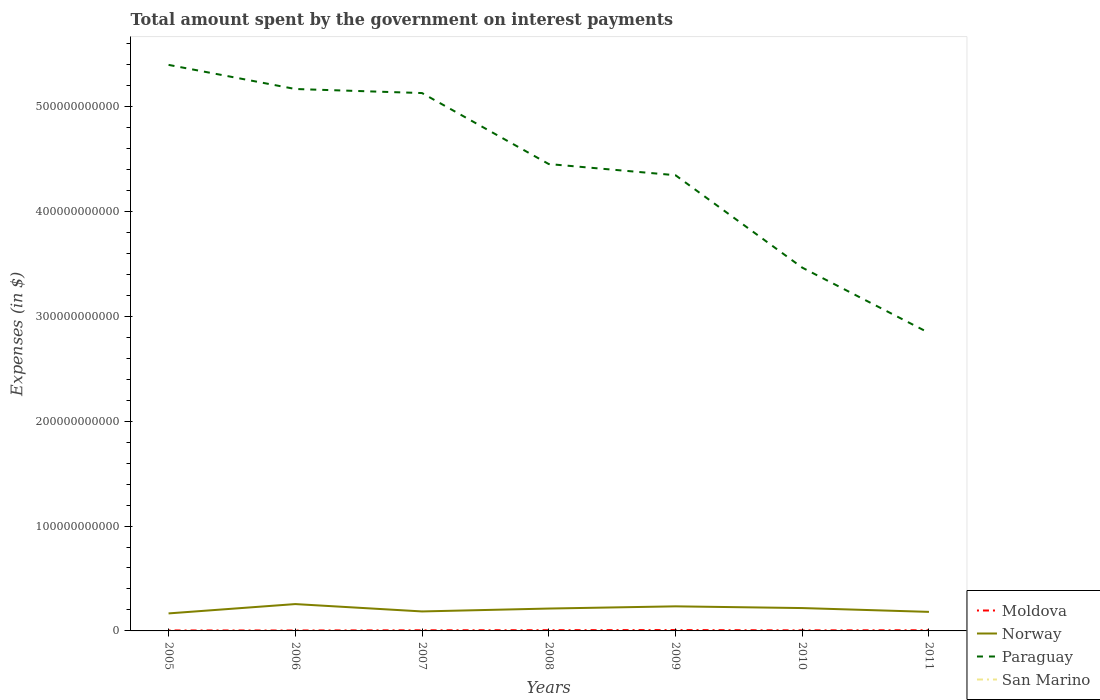How many different coloured lines are there?
Make the answer very short. 4. Across all years, what is the maximum amount spent on interest payments by the government in Norway?
Make the answer very short. 1.67e+1. What is the total amount spent on interest payments by the government in San Marino in the graph?
Your response must be concise. -2.39e+05. What is the difference between the highest and the second highest amount spent on interest payments by the government in Norway?
Make the answer very short. 8.89e+09. What is the difference between the highest and the lowest amount spent on interest payments by the government in Paraguay?
Ensure brevity in your answer.  4. Is the amount spent on interest payments by the government in Moldova strictly greater than the amount spent on interest payments by the government in Norway over the years?
Keep it short and to the point. Yes. How many lines are there?
Offer a terse response. 4. How many years are there in the graph?
Make the answer very short. 7. What is the difference between two consecutive major ticks on the Y-axis?
Provide a succinct answer. 1.00e+11. Are the values on the major ticks of Y-axis written in scientific E-notation?
Ensure brevity in your answer.  No. Does the graph contain any zero values?
Your answer should be very brief. No. Does the graph contain grids?
Provide a short and direct response. No. How many legend labels are there?
Provide a succinct answer. 4. How are the legend labels stacked?
Offer a very short reply. Vertical. What is the title of the graph?
Give a very brief answer. Total amount spent by the government on interest payments. What is the label or title of the Y-axis?
Give a very brief answer. Expenses (in $). What is the Expenses (in $) of Moldova in 2005?
Your response must be concise. 4.70e+08. What is the Expenses (in $) in Norway in 2005?
Your answer should be very brief. 1.67e+1. What is the Expenses (in $) of Paraguay in 2005?
Keep it short and to the point. 5.40e+11. What is the Expenses (in $) in San Marino in 2005?
Give a very brief answer. 2.77e+06. What is the Expenses (in $) of Moldova in 2006?
Your response must be concise. 4.29e+08. What is the Expenses (in $) in Norway in 2006?
Provide a short and direct response. 2.56e+1. What is the Expenses (in $) in Paraguay in 2006?
Your answer should be compact. 5.17e+11. What is the Expenses (in $) in San Marino in 2006?
Your response must be concise. 1.10e+07. What is the Expenses (in $) in Moldova in 2007?
Provide a succinct answer. 6.10e+08. What is the Expenses (in $) of Norway in 2007?
Give a very brief answer. 1.86e+1. What is the Expenses (in $) in Paraguay in 2007?
Your response must be concise. 5.13e+11. What is the Expenses (in $) in San Marino in 2007?
Provide a short and direct response. 1.27e+07. What is the Expenses (in $) of Moldova in 2008?
Offer a terse response. 7.22e+08. What is the Expenses (in $) of Norway in 2008?
Your answer should be very brief. 2.13e+1. What is the Expenses (in $) of Paraguay in 2008?
Give a very brief answer. 4.45e+11. What is the Expenses (in $) in San Marino in 2008?
Ensure brevity in your answer.  5.97e+06. What is the Expenses (in $) in Moldova in 2009?
Offer a very short reply. 8.34e+08. What is the Expenses (in $) of Norway in 2009?
Your answer should be very brief. 2.34e+1. What is the Expenses (in $) of Paraguay in 2009?
Your response must be concise. 4.35e+11. What is the Expenses (in $) in San Marino in 2009?
Your answer should be very brief. 6.45e+06. What is the Expenses (in $) of Moldova in 2010?
Make the answer very short. 5.48e+08. What is the Expenses (in $) of Norway in 2010?
Provide a short and direct response. 2.18e+1. What is the Expenses (in $) in Paraguay in 2010?
Keep it short and to the point. 3.46e+11. What is the Expenses (in $) of San Marino in 2010?
Offer a terse response. 4.65e+06. What is the Expenses (in $) of Moldova in 2011?
Give a very brief answer. 6.62e+08. What is the Expenses (in $) in Norway in 2011?
Your response must be concise. 1.82e+1. What is the Expenses (in $) in Paraguay in 2011?
Keep it short and to the point. 2.84e+11. What is the Expenses (in $) of San Marino in 2011?
Offer a terse response. 4.89e+06. Across all years, what is the maximum Expenses (in $) of Moldova?
Your answer should be very brief. 8.34e+08. Across all years, what is the maximum Expenses (in $) in Norway?
Make the answer very short. 2.56e+1. Across all years, what is the maximum Expenses (in $) of Paraguay?
Ensure brevity in your answer.  5.40e+11. Across all years, what is the maximum Expenses (in $) in San Marino?
Give a very brief answer. 1.27e+07. Across all years, what is the minimum Expenses (in $) in Moldova?
Make the answer very short. 4.29e+08. Across all years, what is the minimum Expenses (in $) in Norway?
Your answer should be very brief. 1.67e+1. Across all years, what is the minimum Expenses (in $) in Paraguay?
Give a very brief answer. 2.84e+11. Across all years, what is the minimum Expenses (in $) of San Marino?
Ensure brevity in your answer.  2.77e+06. What is the total Expenses (in $) in Moldova in the graph?
Your answer should be compact. 4.27e+09. What is the total Expenses (in $) in Norway in the graph?
Your answer should be very brief. 1.46e+11. What is the total Expenses (in $) of Paraguay in the graph?
Offer a very short reply. 3.08e+12. What is the total Expenses (in $) in San Marino in the graph?
Your answer should be very brief. 4.84e+07. What is the difference between the Expenses (in $) in Moldova in 2005 and that in 2006?
Provide a short and direct response. 4.19e+07. What is the difference between the Expenses (in $) of Norway in 2005 and that in 2006?
Offer a very short reply. -8.89e+09. What is the difference between the Expenses (in $) of Paraguay in 2005 and that in 2006?
Offer a very short reply. 2.30e+1. What is the difference between the Expenses (in $) in San Marino in 2005 and that in 2006?
Give a very brief answer. -8.20e+06. What is the difference between the Expenses (in $) of Moldova in 2005 and that in 2007?
Provide a short and direct response. -1.39e+08. What is the difference between the Expenses (in $) in Norway in 2005 and that in 2007?
Provide a short and direct response. -1.88e+09. What is the difference between the Expenses (in $) in Paraguay in 2005 and that in 2007?
Keep it short and to the point. 2.69e+1. What is the difference between the Expenses (in $) in San Marino in 2005 and that in 2007?
Offer a terse response. -9.97e+06. What is the difference between the Expenses (in $) of Moldova in 2005 and that in 2008?
Keep it short and to the point. -2.51e+08. What is the difference between the Expenses (in $) in Norway in 2005 and that in 2008?
Offer a terse response. -4.63e+09. What is the difference between the Expenses (in $) in Paraguay in 2005 and that in 2008?
Your response must be concise. 9.46e+1. What is the difference between the Expenses (in $) of San Marino in 2005 and that in 2008?
Offer a terse response. -3.20e+06. What is the difference between the Expenses (in $) of Moldova in 2005 and that in 2009?
Give a very brief answer. -3.64e+08. What is the difference between the Expenses (in $) in Norway in 2005 and that in 2009?
Your response must be concise. -6.74e+09. What is the difference between the Expenses (in $) in Paraguay in 2005 and that in 2009?
Offer a terse response. 1.05e+11. What is the difference between the Expenses (in $) in San Marino in 2005 and that in 2009?
Your response must be concise. -3.67e+06. What is the difference between the Expenses (in $) of Moldova in 2005 and that in 2010?
Your answer should be compact. -7.71e+07. What is the difference between the Expenses (in $) of Norway in 2005 and that in 2010?
Provide a succinct answer. -5.10e+09. What is the difference between the Expenses (in $) in Paraguay in 2005 and that in 2010?
Provide a succinct answer. 1.93e+11. What is the difference between the Expenses (in $) in San Marino in 2005 and that in 2010?
Your response must be concise. -1.88e+06. What is the difference between the Expenses (in $) of Moldova in 2005 and that in 2011?
Offer a very short reply. -1.92e+08. What is the difference between the Expenses (in $) of Norway in 2005 and that in 2011?
Provide a short and direct response. -1.46e+09. What is the difference between the Expenses (in $) in Paraguay in 2005 and that in 2011?
Ensure brevity in your answer.  2.56e+11. What is the difference between the Expenses (in $) in San Marino in 2005 and that in 2011?
Ensure brevity in your answer.  -2.12e+06. What is the difference between the Expenses (in $) of Moldova in 2006 and that in 2007?
Offer a terse response. -1.81e+08. What is the difference between the Expenses (in $) of Norway in 2006 and that in 2007?
Offer a very short reply. 7.01e+09. What is the difference between the Expenses (in $) of Paraguay in 2006 and that in 2007?
Make the answer very short. 3.87e+09. What is the difference between the Expenses (in $) of San Marino in 2006 and that in 2007?
Your response must be concise. -1.77e+06. What is the difference between the Expenses (in $) of Moldova in 2006 and that in 2008?
Ensure brevity in your answer.  -2.93e+08. What is the difference between the Expenses (in $) in Norway in 2006 and that in 2008?
Keep it short and to the point. 4.26e+09. What is the difference between the Expenses (in $) of Paraguay in 2006 and that in 2008?
Offer a very short reply. 7.16e+1. What is the difference between the Expenses (in $) in San Marino in 2006 and that in 2008?
Your response must be concise. 5.00e+06. What is the difference between the Expenses (in $) in Moldova in 2006 and that in 2009?
Make the answer very short. -4.06e+08. What is the difference between the Expenses (in $) in Norway in 2006 and that in 2009?
Keep it short and to the point. 2.15e+09. What is the difference between the Expenses (in $) in Paraguay in 2006 and that in 2009?
Make the answer very short. 8.22e+1. What is the difference between the Expenses (in $) in San Marino in 2006 and that in 2009?
Provide a short and direct response. 4.52e+06. What is the difference between the Expenses (in $) of Moldova in 2006 and that in 2010?
Make the answer very short. -1.19e+08. What is the difference between the Expenses (in $) in Norway in 2006 and that in 2010?
Your answer should be compact. 3.79e+09. What is the difference between the Expenses (in $) in Paraguay in 2006 and that in 2010?
Offer a very short reply. 1.70e+11. What is the difference between the Expenses (in $) in San Marino in 2006 and that in 2010?
Provide a short and direct response. 6.32e+06. What is the difference between the Expenses (in $) in Moldova in 2006 and that in 2011?
Make the answer very short. -2.34e+08. What is the difference between the Expenses (in $) of Norway in 2006 and that in 2011?
Keep it short and to the point. 7.43e+09. What is the difference between the Expenses (in $) of Paraguay in 2006 and that in 2011?
Ensure brevity in your answer.  2.33e+11. What is the difference between the Expenses (in $) in San Marino in 2006 and that in 2011?
Ensure brevity in your answer.  6.08e+06. What is the difference between the Expenses (in $) in Moldova in 2007 and that in 2008?
Your response must be concise. -1.12e+08. What is the difference between the Expenses (in $) of Norway in 2007 and that in 2008?
Ensure brevity in your answer.  -2.75e+09. What is the difference between the Expenses (in $) in Paraguay in 2007 and that in 2008?
Your answer should be very brief. 6.77e+1. What is the difference between the Expenses (in $) of San Marino in 2007 and that in 2008?
Provide a short and direct response. 6.77e+06. What is the difference between the Expenses (in $) in Moldova in 2007 and that in 2009?
Provide a succinct answer. -2.24e+08. What is the difference between the Expenses (in $) in Norway in 2007 and that in 2009?
Keep it short and to the point. -4.86e+09. What is the difference between the Expenses (in $) in Paraguay in 2007 and that in 2009?
Offer a terse response. 7.83e+1. What is the difference between the Expenses (in $) of San Marino in 2007 and that in 2009?
Your answer should be very brief. 6.29e+06. What is the difference between the Expenses (in $) of Moldova in 2007 and that in 2010?
Provide a short and direct response. 6.22e+07. What is the difference between the Expenses (in $) of Norway in 2007 and that in 2010?
Your response must be concise. -3.22e+09. What is the difference between the Expenses (in $) of Paraguay in 2007 and that in 2010?
Provide a short and direct response. 1.66e+11. What is the difference between the Expenses (in $) in San Marino in 2007 and that in 2010?
Give a very brief answer. 8.09e+06. What is the difference between the Expenses (in $) of Moldova in 2007 and that in 2011?
Your answer should be compact. -5.26e+07. What is the difference between the Expenses (in $) in Norway in 2007 and that in 2011?
Your response must be concise. 4.20e+08. What is the difference between the Expenses (in $) in Paraguay in 2007 and that in 2011?
Make the answer very short. 2.29e+11. What is the difference between the Expenses (in $) of San Marino in 2007 and that in 2011?
Provide a short and direct response. 7.85e+06. What is the difference between the Expenses (in $) in Moldova in 2008 and that in 2009?
Your answer should be compact. -1.13e+08. What is the difference between the Expenses (in $) of Norway in 2008 and that in 2009?
Your response must be concise. -2.11e+09. What is the difference between the Expenses (in $) in Paraguay in 2008 and that in 2009?
Provide a short and direct response. 1.06e+1. What is the difference between the Expenses (in $) of San Marino in 2008 and that in 2009?
Keep it short and to the point. -4.76e+05. What is the difference between the Expenses (in $) of Moldova in 2008 and that in 2010?
Keep it short and to the point. 1.74e+08. What is the difference between the Expenses (in $) of Norway in 2008 and that in 2010?
Offer a terse response. -4.70e+08. What is the difference between the Expenses (in $) of Paraguay in 2008 and that in 2010?
Ensure brevity in your answer.  9.87e+1. What is the difference between the Expenses (in $) of San Marino in 2008 and that in 2010?
Offer a terse response. 1.32e+06. What is the difference between the Expenses (in $) in Moldova in 2008 and that in 2011?
Your response must be concise. 5.92e+07. What is the difference between the Expenses (in $) of Norway in 2008 and that in 2011?
Offer a very short reply. 3.17e+09. What is the difference between the Expenses (in $) in Paraguay in 2008 and that in 2011?
Provide a succinct answer. 1.61e+11. What is the difference between the Expenses (in $) of San Marino in 2008 and that in 2011?
Ensure brevity in your answer.  1.08e+06. What is the difference between the Expenses (in $) of Moldova in 2009 and that in 2010?
Offer a terse response. 2.87e+08. What is the difference between the Expenses (in $) of Norway in 2009 and that in 2010?
Your answer should be compact. 1.64e+09. What is the difference between the Expenses (in $) of Paraguay in 2009 and that in 2010?
Make the answer very short. 8.81e+1. What is the difference between the Expenses (in $) in San Marino in 2009 and that in 2010?
Offer a terse response. 1.79e+06. What is the difference between the Expenses (in $) of Moldova in 2009 and that in 2011?
Your response must be concise. 1.72e+08. What is the difference between the Expenses (in $) in Norway in 2009 and that in 2011?
Keep it short and to the point. 5.28e+09. What is the difference between the Expenses (in $) in Paraguay in 2009 and that in 2011?
Make the answer very short. 1.50e+11. What is the difference between the Expenses (in $) in San Marino in 2009 and that in 2011?
Your response must be concise. 1.56e+06. What is the difference between the Expenses (in $) of Moldova in 2010 and that in 2011?
Ensure brevity in your answer.  -1.15e+08. What is the difference between the Expenses (in $) in Norway in 2010 and that in 2011?
Your response must be concise. 3.64e+09. What is the difference between the Expenses (in $) of Paraguay in 2010 and that in 2011?
Offer a terse response. 6.23e+1. What is the difference between the Expenses (in $) of San Marino in 2010 and that in 2011?
Your answer should be compact. -2.39e+05. What is the difference between the Expenses (in $) of Moldova in 2005 and the Expenses (in $) of Norway in 2006?
Your answer should be compact. -2.51e+1. What is the difference between the Expenses (in $) in Moldova in 2005 and the Expenses (in $) in Paraguay in 2006?
Your answer should be very brief. -5.16e+11. What is the difference between the Expenses (in $) in Moldova in 2005 and the Expenses (in $) in San Marino in 2006?
Your answer should be compact. 4.60e+08. What is the difference between the Expenses (in $) in Norway in 2005 and the Expenses (in $) in Paraguay in 2006?
Offer a very short reply. -5.00e+11. What is the difference between the Expenses (in $) of Norway in 2005 and the Expenses (in $) of San Marino in 2006?
Your response must be concise. 1.67e+1. What is the difference between the Expenses (in $) of Paraguay in 2005 and the Expenses (in $) of San Marino in 2006?
Provide a short and direct response. 5.40e+11. What is the difference between the Expenses (in $) in Moldova in 2005 and the Expenses (in $) in Norway in 2007?
Make the answer very short. -1.81e+1. What is the difference between the Expenses (in $) in Moldova in 2005 and the Expenses (in $) in Paraguay in 2007?
Give a very brief answer. -5.12e+11. What is the difference between the Expenses (in $) in Moldova in 2005 and the Expenses (in $) in San Marino in 2007?
Your answer should be compact. 4.58e+08. What is the difference between the Expenses (in $) of Norway in 2005 and the Expenses (in $) of Paraguay in 2007?
Provide a short and direct response. -4.96e+11. What is the difference between the Expenses (in $) of Norway in 2005 and the Expenses (in $) of San Marino in 2007?
Your response must be concise. 1.67e+1. What is the difference between the Expenses (in $) in Paraguay in 2005 and the Expenses (in $) in San Marino in 2007?
Provide a succinct answer. 5.40e+11. What is the difference between the Expenses (in $) in Moldova in 2005 and the Expenses (in $) in Norway in 2008?
Give a very brief answer. -2.09e+1. What is the difference between the Expenses (in $) in Moldova in 2005 and the Expenses (in $) in Paraguay in 2008?
Offer a terse response. -4.45e+11. What is the difference between the Expenses (in $) in Moldova in 2005 and the Expenses (in $) in San Marino in 2008?
Offer a very short reply. 4.65e+08. What is the difference between the Expenses (in $) of Norway in 2005 and the Expenses (in $) of Paraguay in 2008?
Your answer should be compact. -4.28e+11. What is the difference between the Expenses (in $) in Norway in 2005 and the Expenses (in $) in San Marino in 2008?
Give a very brief answer. 1.67e+1. What is the difference between the Expenses (in $) of Paraguay in 2005 and the Expenses (in $) of San Marino in 2008?
Ensure brevity in your answer.  5.40e+11. What is the difference between the Expenses (in $) in Moldova in 2005 and the Expenses (in $) in Norway in 2009?
Provide a short and direct response. -2.30e+1. What is the difference between the Expenses (in $) in Moldova in 2005 and the Expenses (in $) in Paraguay in 2009?
Give a very brief answer. -4.34e+11. What is the difference between the Expenses (in $) of Moldova in 2005 and the Expenses (in $) of San Marino in 2009?
Provide a short and direct response. 4.64e+08. What is the difference between the Expenses (in $) of Norway in 2005 and the Expenses (in $) of Paraguay in 2009?
Keep it short and to the point. -4.18e+11. What is the difference between the Expenses (in $) in Norway in 2005 and the Expenses (in $) in San Marino in 2009?
Offer a terse response. 1.67e+1. What is the difference between the Expenses (in $) of Paraguay in 2005 and the Expenses (in $) of San Marino in 2009?
Your answer should be very brief. 5.40e+11. What is the difference between the Expenses (in $) of Moldova in 2005 and the Expenses (in $) of Norway in 2010?
Keep it short and to the point. -2.13e+1. What is the difference between the Expenses (in $) in Moldova in 2005 and the Expenses (in $) in Paraguay in 2010?
Your answer should be very brief. -3.46e+11. What is the difference between the Expenses (in $) of Moldova in 2005 and the Expenses (in $) of San Marino in 2010?
Offer a very short reply. 4.66e+08. What is the difference between the Expenses (in $) in Norway in 2005 and the Expenses (in $) in Paraguay in 2010?
Keep it short and to the point. -3.30e+11. What is the difference between the Expenses (in $) of Norway in 2005 and the Expenses (in $) of San Marino in 2010?
Provide a succinct answer. 1.67e+1. What is the difference between the Expenses (in $) in Paraguay in 2005 and the Expenses (in $) in San Marino in 2010?
Provide a short and direct response. 5.40e+11. What is the difference between the Expenses (in $) of Moldova in 2005 and the Expenses (in $) of Norway in 2011?
Your answer should be very brief. -1.77e+1. What is the difference between the Expenses (in $) in Moldova in 2005 and the Expenses (in $) in Paraguay in 2011?
Provide a succinct answer. -2.84e+11. What is the difference between the Expenses (in $) in Moldova in 2005 and the Expenses (in $) in San Marino in 2011?
Provide a short and direct response. 4.66e+08. What is the difference between the Expenses (in $) of Norway in 2005 and the Expenses (in $) of Paraguay in 2011?
Offer a terse response. -2.67e+11. What is the difference between the Expenses (in $) of Norway in 2005 and the Expenses (in $) of San Marino in 2011?
Give a very brief answer. 1.67e+1. What is the difference between the Expenses (in $) in Paraguay in 2005 and the Expenses (in $) in San Marino in 2011?
Keep it short and to the point. 5.40e+11. What is the difference between the Expenses (in $) of Moldova in 2006 and the Expenses (in $) of Norway in 2007?
Your answer should be very brief. -1.82e+1. What is the difference between the Expenses (in $) in Moldova in 2006 and the Expenses (in $) in Paraguay in 2007?
Keep it short and to the point. -5.12e+11. What is the difference between the Expenses (in $) of Moldova in 2006 and the Expenses (in $) of San Marino in 2007?
Give a very brief answer. 4.16e+08. What is the difference between the Expenses (in $) of Norway in 2006 and the Expenses (in $) of Paraguay in 2007?
Give a very brief answer. -4.87e+11. What is the difference between the Expenses (in $) in Norway in 2006 and the Expenses (in $) in San Marino in 2007?
Your response must be concise. 2.56e+1. What is the difference between the Expenses (in $) in Paraguay in 2006 and the Expenses (in $) in San Marino in 2007?
Give a very brief answer. 5.17e+11. What is the difference between the Expenses (in $) of Moldova in 2006 and the Expenses (in $) of Norway in 2008?
Ensure brevity in your answer.  -2.09e+1. What is the difference between the Expenses (in $) in Moldova in 2006 and the Expenses (in $) in Paraguay in 2008?
Make the answer very short. -4.45e+11. What is the difference between the Expenses (in $) of Moldova in 2006 and the Expenses (in $) of San Marino in 2008?
Your answer should be very brief. 4.23e+08. What is the difference between the Expenses (in $) of Norway in 2006 and the Expenses (in $) of Paraguay in 2008?
Give a very brief answer. -4.20e+11. What is the difference between the Expenses (in $) of Norway in 2006 and the Expenses (in $) of San Marino in 2008?
Ensure brevity in your answer.  2.56e+1. What is the difference between the Expenses (in $) of Paraguay in 2006 and the Expenses (in $) of San Marino in 2008?
Provide a short and direct response. 5.17e+11. What is the difference between the Expenses (in $) of Moldova in 2006 and the Expenses (in $) of Norway in 2009?
Offer a very short reply. -2.30e+1. What is the difference between the Expenses (in $) of Moldova in 2006 and the Expenses (in $) of Paraguay in 2009?
Make the answer very short. -4.34e+11. What is the difference between the Expenses (in $) in Moldova in 2006 and the Expenses (in $) in San Marino in 2009?
Your answer should be compact. 4.22e+08. What is the difference between the Expenses (in $) of Norway in 2006 and the Expenses (in $) of Paraguay in 2009?
Give a very brief answer. -4.09e+11. What is the difference between the Expenses (in $) of Norway in 2006 and the Expenses (in $) of San Marino in 2009?
Offer a terse response. 2.56e+1. What is the difference between the Expenses (in $) in Paraguay in 2006 and the Expenses (in $) in San Marino in 2009?
Ensure brevity in your answer.  5.17e+11. What is the difference between the Expenses (in $) of Moldova in 2006 and the Expenses (in $) of Norway in 2010?
Offer a terse response. -2.14e+1. What is the difference between the Expenses (in $) of Moldova in 2006 and the Expenses (in $) of Paraguay in 2010?
Ensure brevity in your answer.  -3.46e+11. What is the difference between the Expenses (in $) of Moldova in 2006 and the Expenses (in $) of San Marino in 2010?
Your answer should be very brief. 4.24e+08. What is the difference between the Expenses (in $) of Norway in 2006 and the Expenses (in $) of Paraguay in 2010?
Offer a very short reply. -3.21e+11. What is the difference between the Expenses (in $) in Norway in 2006 and the Expenses (in $) in San Marino in 2010?
Offer a terse response. 2.56e+1. What is the difference between the Expenses (in $) of Paraguay in 2006 and the Expenses (in $) of San Marino in 2010?
Your response must be concise. 5.17e+11. What is the difference between the Expenses (in $) in Moldova in 2006 and the Expenses (in $) in Norway in 2011?
Offer a very short reply. -1.77e+1. What is the difference between the Expenses (in $) in Moldova in 2006 and the Expenses (in $) in Paraguay in 2011?
Offer a very short reply. -2.84e+11. What is the difference between the Expenses (in $) in Moldova in 2006 and the Expenses (in $) in San Marino in 2011?
Provide a short and direct response. 4.24e+08. What is the difference between the Expenses (in $) in Norway in 2006 and the Expenses (in $) in Paraguay in 2011?
Offer a very short reply. -2.59e+11. What is the difference between the Expenses (in $) in Norway in 2006 and the Expenses (in $) in San Marino in 2011?
Your answer should be compact. 2.56e+1. What is the difference between the Expenses (in $) of Paraguay in 2006 and the Expenses (in $) of San Marino in 2011?
Your answer should be compact. 5.17e+11. What is the difference between the Expenses (in $) of Moldova in 2007 and the Expenses (in $) of Norway in 2008?
Keep it short and to the point. -2.07e+1. What is the difference between the Expenses (in $) in Moldova in 2007 and the Expenses (in $) in Paraguay in 2008?
Your answer should be very brief. -4.45e+11. What is the difference between the Expenses (in $) of Moldova in 2007 and the Expenses (in $) of San Marino in 2008?
Your response must be concise. 6.04e+08. What is the difference between the Expenses (in $) of Norway in 2007 and the Expenses (in $) of Paraguay in 2008?
Your answer should be compact. -4.27e+11. What is the difference between the Expenses (in $) in Norway in 2007 and the Expenses (in $) in San Marino in 2008?
Your answer should be very brief. 1.86e+1. What is the difference between the Expenses (in $) in Paraguay in 2007 and the Expenses (in $) in San Marino in 2008?
Offer a very short reply. 5.13e+11. What is the difference between the Expenses (in $) of Moldova in 2007 and the Expenses (in $) of Norway in 2009?
Your response must be concise. -2.28e+1. What is the difference between the Expenses (in $) of Moldova in 2007 and the Expenses (in $) of Paraguay in 2009?
Your response must be concise. -4.34e+11. What is the difference between the Expenses (in $) in Moldova in 2007 and the Expenses (in $) in San Marino in 2009?
Provide a succinct answer. 6.03e+08. What is the difference between the Expenses (in $) in Norway in 2007 and the Expenses (in $) in Paraguay in 2009?
Your answer should be very brief. -4.16e+11. What is the difference between the Expenses (in $) of Norway in 2007 and the Expenses (in $) of San Marino in 2009?
Your response must be concise. 1.86e+1. What is the difference between the Expenses (in $) of Paraguay in 2007 and the Expenses (in $) of San Marino in 2009?
Ensure brevity in your answer.  5.13e+11. What is the difference between the Expenses (in $) in Moldova in 2007 and the Expenses (in $) in Norway in 2010?
Offer a very short reply. -2.12e+1. What is the difference between the Expenses (in $) of Moldova in 2007 and the Expenses (in $) of Paraguay in 2010?
Your answer should be compact. -3.46e+11. What is the difference between the Expenses (in $) in Moldova in 2007 and the Expenses (in $) in San Marino in 2010?
Ensure brevity in your answer.  6.05e+08. What is the difference between the Expenses (in $) in Norway in 2007 and the Expenses (in $) in Paraguay in 2010?
Make the answer very short. -3.28e+11. What is the difference between the Expenses (in $) in Norway in 2007 and the Expenses (in $) in San Marino in 2010?
Your response must be concise. 1.86e+1. What is the difference between the Expenses (in $) in Paraguay in 2007 and the Expenses (in $) in San Marino in 2010?
Give a very brief answer. 5.13e+11. What is the difference between the Expenses (in $) in Moldova in 2007 and the Expenses (in $) in Norway in 2011?
Offer a very short reply. -1.76e+1. What is the difference between the Expenses (in $) in Moldova in 2007 and the Expenses (in $) in Paraguay in 2011?
Your response must be concise. -2.84e+11. What is the difference between the Expenses (in $) in Moldova in 2007 and the Expenses (in $) in San Marino in 2011?
Provide a succinct answer. 6.05e+08. What is the difference between the Expenses (in $) in Norway in 2007 and the Expenses (in $) in Paraguay in 2011?
Provide a succinct answer. -2.66e+11. What is the difference between the Expenses (in $) of Norway in 2007 and the Expenses (in $) of San Marino in 2011?
Provide a succinct answer. 1.86e+1. What is the difference between the Expenses (in $) of Paraguay in 2007 and the Expenses (in $) of San Marino in 2011?
Keep it short and to the point. 5.13e+11. What is the difference between the Expenses (in $) in Moldova in 2008 and the Expenses (in $) in Norway in 2009?
Your answer should be very brief. -2.27e+1. What is the difference between the Expenses (in $) of Moldova in 2008 and the Expenses (in $) of Paraguay in 2009?
Provide a short and direct response. -4.34e+11. What is the difference between the Expenses (in $) in Moldova in 2008 and the Expenses (in $) in San Marino in 2009?
Offer a very short reply. 7.15e+08. What is the difference between the Expenses (in $) in Norway in 2008 and the Expenses (in $) in Paraguay in 2009?
Offer a terse response. -4.13e+11. What is the difference between the Expenses (in $) of Norway in 2008 and the Expenses (in $) of San Marino in 2009?
Provide a short and direct response. 2.13e+1. What is the difference between the Expenses (in $) in Paraguay in 2008 and the Expenses (in $) in San Marino in 2009?
Give a very brief answer. 4.45e+11. What is the difference between the Expenses (in $) in Moldova in 2008 and the Expenses (in $) in Norway in 2010?
Your response must be concise. -2.11e+1. What is the difference between the Expenses (in $) of Moldova in 2008 and the Expenses (in $) of Paraguay in 2010?
Provide a short and direct response. -3.46e+11. What is the difference between the Expenses (in $) in Moldova in 2008 and the Expenses (in $) in San Marino in 2010?
Offer a very short reply. 7.17e+08. What is the difference between the Expenses (in $) in Norway in 2008 and the Expenses (in $) in Paraguay in 2010?
Give a very brief answer. -3.25e+11. What is the difference between the Expenses (in $) in Norway in 2008 and the Expenses (in $) in San Marino in 2010?
Make the answer very short. 2.13e+1. What is the difference between the Expenses (in $) in Paraguay in 2008 and the Expenses (in $) in San Marino in 2010?
Give a very brief answer. 4.45e+11. What is the difference between the Expenses (in $) of Moldova in 2008 and the Expenses (in $) of Norway in 2011?
Provide a short and direct response. -1.74e+1. What is the difference between the Expenses (in $) in Moldova in 2008 and the Expenses (in $) in Paraguay in 2011?
Your answer should be compact. -2.83e+11. What is the difference between the Expenses (in $) of Moldova in 2008 and the Expenses (in $) of San Marino in 2011?
Make the answer very short. 7.17e+08. What is the difference between the Expenses (in $) of Norway in 2008 and the Expenses (in $) of Paraguay in 2011?
Make the answer very short. -2.63e+11. What is the difference between the Expenses (in $) of Norway in 2008 and the Expenses (in $) of San Marino in 2011?
Your answer should be very brief. 2.13e+1. What is the difference between the Expenses (in $) in Paraguay in 2008 and the Expenses (in $) in San Marino in 2011?
Your answer should be very brief. 4.45e+11. What is the difference between the Expenses (in $) of Moldova in 2009 and the Expenses (in $) of Norway in 2010?
Keep it short and to the point. -2.10e+1. What is the difference between the Expenses (in $) in Moldova in 2009 and the Expenses (in $) in Paraguay in 2010?
Provide a succinct answer. -3.46e+11. What is the difference between the Expenses (in $) of Moldova in 2009 and the Expenses (in $) of San Marino in 2010?
Keep it short and to the point. 8.30e+08. What is the difference between the Expenses (in $) of Norway in 2009 and the Expenses (in $) of Paraguay in 2010?
Your answer should be compact. -3.23e+11. What is the difference between the Expenses (in $) of Norway in 2009 and the Expenses (in $) of San Marino in 2010?
Make the answer very short. 2.34e+1. What is the difference between the Expenses (in $) of Paraguay in 2009 and the Expenses (in $) of San Marino in 2010?
Give a very brief answer. 4.35e+11. What is the difference between the Expenses (in $) in Moldova in 2009 and the Expenses (in $) in Norway in 2011?
Keep it short and to the point. -1.73e+1. What is the difference between the Expenses (in $) of Moldova in 2009 and the Expenses (in $) of Paraguay in 2011?
Keep it short and to the point. -2.83e+11. What is the difference between the Expenses (in $) in Moldova in 2009 and the Expenses (in $) in San Marino in 2011?
Your response must be concise. 8.29e+08. What is the difference between the Expenses (in $) of Norway in 2009 and the Expenses (in $) of Paraguay in 2011?
Make the answer very short. -2.61e+11. What is the difference between the Expenses (in $) in Norway in 2009 and the Expenses (in $) in San Marino in 2011?
Your answer should be compact. 2.34e+1. What is the difference between the Expenses (in $) in Paraguay in 2009 and the Expenses (in $) in San Marino in 2011?
Keep it short and to the point. 4.35e+11. What is the difference between the Expenses (in $) of Moldova in 2010 and the Expenses (in $) of Norway in 2011?
Offer a terse response. -1.76e+1. What is the difference between the Expenses (in $) in Moldova in 2010 and the Expenses (in $) in Paraguay in 2011?
Give a very brief answer. -2.84e+11. What is the difference between the Expenses (in $) in Moldova in 2010 and the Expenses (in $) in San Marino in 2011?
Provide a succinct answer. 5.43e+08. What is the difference between the Expenses (in $) of Norway in 2010 and the Expenses (in $) of Paraguay in 2011?
Provide a succinct answer. -2.62e+11. What is the difference between the Expenses (in $) of Norway in 2010 and the Expenses (in $) of San Marino in 2011?
Give a very brief answer. 2.18e+1. What is the difference between the Expenses (in $) in Paraguay in 2010 and the Expenses (in $) in San Marino in 2011?
Offer a terse response. 3.46e+11. What is the average Expenses (in $) of Moldova per year?
Make the answer very short. 6.11e+08. What is the average Expenses (in $) of Norway per year?
Make the answer very short. 2.08e+1. What is the average Expenses (in $) in Paraguay per year?
Offer a terse response. 4.40e+11. What is the average Expenses (in $) of San Marino per year?
Your response must be concise. 6.92e+06. In the year 2005, what is the difference between the Expenses (in $) in Moldova and Expenses (in $) in Norway?
Offer a terse response. -1.62e+1. In the year 2005, what is the difference between the Expenses (in $) in Moldova and Expenses (in $) in Paraguay?
Your response must be concise. -5.39e+11. In the year 2005, what is the difference between the Expenses (in $) in Moldova and Expenses (in $) in San Marino?
Ensure brevity in your answer.  4.68e+08. In the year 2005, what is the difference between the Expenses (in $) in Norway and Expenses (in $) in Paraguay?
Your response must be concise. -5.23e+11. In the year 2005, what is the difference between the Expenses (in $) of Norway and Expenses (in $) of San Marino?
Provide a succinct answer. 1.67e+1. In the year 2005, what is the difference between the Expenses (in $) in Paraguay and Expenses (in $) in San Marino?
Provide a succinct answer. 5.40e+11. In the year 2006, what is the difference between the Expenses (in $) of Moldova and Expenses (in $) of Norway?
Make the answer very short. -2.52e+1. In the year 2006, what is the difference between the Expenses (in $) in Moldova and Expenses (in $) in Paraguay?
Offer a terse response. -5.16e+11. In the year 2006, what is the difference between the Expenses (in $) in Moldova and Expenses (in $) in San Marino?
Ensure brevity in your answer.  4.18e+08. In the year 2006, what is the difference between the Expenses (in $) in Norway and Expenses (in $) in Paraguay?
Give a very brief answer. -4.91e+11. In the year 2006, what is the difference between the Expenses (in $) in Norway and Expenses (in $) in San Marino?
Make the answer very short. 2.56e+1. In the year 2006, what is the difference between the Expenses (in $) in Paraguay and Expenses (in $) in San Marino?
Your response must be concise. 5.17e+11. In the year 2007, what is the difference between the Expenses (in $) of Moldova and Expenses (in $) of Norway?
Offer a very short reply. -1.80e+1. In the year 2007, what is the difference between the Expenses (in $) in Moldova and Expenses (in $) in Paraguay?
Your response must be concise. -5.12e+11. In the year 2007, what is the difference between the Expenses (in $) of Moldova and Expenses (in $) of San Marino?
Your response must be concise. 5.97e+08. In the year 2007, what is the difference between the Expenses (in $) in Norway and Expenses (in $) in Paraguay?
Keep it short and to the point. -4.94e+11. In the year 2007, what is the difference between the Expenses (in $) in Norway and Expenses (in $) in San Marino?
Your answer should be very brief. 1.86e+1. In the year 2007, what is the difference between the Expenses (in $) of Paraguay and Expenses (in $) of San Marino?
Your answer should be compact. 5.13e+11. In the year 2008, what is the difference between the Expenses (in $) in Moldova and Expenses (in $) in Norway?
Keep it short and to the point. -2.06e+1. In the year 2008, what is the difference between the Expenses (in $) of Moldova and Expenses (in $) of Paraguay?
Give a very brief answer. -4.44e+11. In the year 2008, what is the difference between the Expenses (in $) in Moldova and Expenses (in $) in San Marino?
Offer a terse response. 7.16e+08. In the year 2008, what is the difference between the Expenses (in $) in Norway and Expenses (in $) in Paraguay?
Your answer should be compact. -4.24e+11. In the year 2008, what is the difference between the Expenses (in $) in Norway and Expenses (in $) in San Marino?
Your response must be concise. 2.13e+1. In the year 2008, what is the difference between the Expenses (in $) in Paraguay and Expenses (in $) in San Marino?
Provide a short and direct response. 4.45e+11. In the year 2009, what is the difference between the Expenses (in $) in Moldova and Expenses (in $) in Norway?
Your response must be concise. -2.26e+1. In the year 2009, what is the difference between the Expenses (in $) in Moldova and Expenses (in $) in Paraguay?
Provide a short and direct response. -4.34e+11. In the year 2009, what is the difference between the Expenses (in $) in Moldova and Expenses (in $) in San Marino?
Provide a succinct answer. 8.28e+08. In the year 2009, what is the difference between the Expenses (in $) in Norway and Expenses (in $) in Paraguay?
Offer a very short reply. -4.11e+11. In the year 2009, what is the difference between the Expenses (in $) in Norway and Expenses (in $) in San Marino?
Make the answer very short. 2.34e+1. In the year 2009, what is the difference between the Expenses (in $) of Paraguay and Expenses (in $) of San Marino?
Your answer should be very brief. 4.34e+11. In the year 2010, what is the difference between the Expenses (in $) in Moldova and Expenses (in $) in Norway?
Give a very brief answer. -2.13e+1. In the year 2010, what is the difference between the Expenses (in $) of Moldova and Expenses (in $) of Paraguay?
Keep it short and to the point. -3.46e+11. In the year 2010, what is the difference between the Expenses (in $) in Moldova and Expenses (in $) in San Marino?
Provide a succinct answer. 5.43e+08. In the year 2010, what is the difference between the Expenses (in $) of Norway and Expenses (in $) of Paraguay?
Offer a terse response. -3.25e+11. In the year 2010, what is the difference between the Expenses (in $) in Norway and Expenses (in $) in San Marino?
Your answer should be very brief. 2.18e+1. In the year 2010, what is the difference between the Expenses (in $) of Paraguay and Expenses (in $) of San Marino?
Offer a very short reply. 3.46e+11. In the year 2011, what is the difference between the Expenses (in $) in Moldova and Expenses (in $) in Norway?
Your response must be concise. -1.75e+1. In the year 2011, what is the difference between the Expenses (in $) in Moldova and Expenses (in $) in Paraguay?
Offer a terse response. -2.83e+11. In the year 2011, what is the difference between the Expenses (in $) in Moldova and Expenses (in $) in San Marino?
Ensure brevity in your answer.  6.58e+08. In the year 2011, what is the difference between the Expenses (in $) in Norway and Expenses (in $) in Paraguay?
Your answer should be very brief. -2.66e+11. In the year 2011, what is the difference between the Expenses (in $) in Norway and Expenses (in $) in San Marino?
Make the answer very short. 1.82e+1. In the year 2011, what is the difference between the Expenses (in $) of Paraguay and Expenses (in $) of San Marino?
Provide a short and direct response. 2.84e+11. What is the ratio of the Expenses (in $) of Moldova in 2005 to that in 2006?
Make the answer very short. 1.1. What is the ratio of the Expenses (in $) in Norway in 2005 to that in 2006?
Offer a very short reply. 0.65. What is the ratio of the Expenses (in $) of Paraguay in 2005 to that in 2006?
Provide a short and direct response. 1.04. What is the ratio of the Expenses (in $) in San Marino in 2005 to that in 2006?
Ensure brevity in your answer.  0.25. What is the ratio of the Expenses (in $) in Moldova in 2005 to that in 2007?
Give a very brief answer. 0.77. What is the ratio of the Expenses (in $) of Norway in 2005 to that in 2007?
Ensure brevity in your answer.  0.9. What is the ratio of the Expenses (in $) of Paraguay in 2005 to that in 2007?
Make the answer very short. 1.05. What is the ratio of the Expenses (in $) of San Marino in 2005 to that in 2007?
Your answer should be compact. 0.22. What is the ratio of the Expenses (in $) in Moldova in 2005 to that in 2008?
Offer a terse response. 0.65. What is the ratio of the Expenses (in $) in Norway in 2005 to that in 2008?
Your response must be concise. 0.78. What is the ratio of the Expenses (in $) of Paraguay in 2005 to that in 2008?
Your response must be concise. 1.21. What is the ratio of the Expenses (in $) in San Marino in 2005 to that in 2008?
Your answer should be compact. 0.46. What is the ratio of the Expenses (in $) in Moldova in 2005 to that in 2009?
Your response must be concise. 0.56. What is the ratio of the Expenses (in $) of Norway in 2005 to that in 2009?
Your response must be concise. 0.71. What is the ratio of the Expenses (in $) in Paraguay in 2005 to that in 2009?
Keep it short and to the point. 1.24. What is the ratio of the Expenses (in $) of San Marino in 2005 to that in 2009?
Your answer should be compact. 0.43. What is the ratio of the Expenses (in $) in Moldova in 2005 to that in 2010?
Provide a short and direct response. 0.86. What is the ratio of the Expenses (in $) in Norway in 2005 to that in 2010?
Offer a terse response. 0.77. What is the ratio of the Expenses (in $) in Paraguay in 2005 to that in 2010?
Ensure brevity in your answer.  1.56. What is the ratio of the Expenses (in $) in San Marino in 2005 to that in 2010?
Give a very brief answer. 0.6. What is the ratio of the Expenses (in $) in Moldova in 2005 to that in 2011?
Give a very brief answer. 0.71. What is the ratio of the Expenses (in $) of Norway in 2005 to that in 2011?
Give a very brief answer. 0.92. What is the ratio of the Expenses (in $) in Paraguay in 2005 to that in 2011?
Provide a succinct answer. 1.9. What is the ratio of the Expenses (in $) in San Marino in 2005 to that in 2011?
Keep it short and to the point. 0.57. What is the ratio of the Expenses (in $) in Moldova in 2006 to that in 2007?
Your answer should be very brief. 0.7. What is the ratio of the Expenses (in $) of Norway in 2006 to that in 2007?
Give a very brief answer. 1.38. What is the ratio of the Expenses (in $) of Paraguay in 2006 to that in 2007?
Give a very brief answer. 1.01. What is the ratio of the Expenses (in $) of San Marino in 2006 to that in 2007?
Your answer should be compact. 0.86. What is the ratio of the Expenses (in $) in Moldova in 2006 to that in 2008?
Give a very brief answer. 0.59. What is the ratio of the Expenses (in $) in Norway in 2006 to that in 2008?
Make the answer very short. 1.2. What is the ratio of the Expenses (in $) of Paraguay in 2006 to that in 2008?
Your response must be concise. 1.16. What is the ratio of the Expenses (in $) in San Marino in 2006 to that in 2008?
Your answer should be very brief. 1.84. What is the ratio of the Expenses (in $) of Moldova in 2006 to that in 2009?
Your answer should be compact. 0.51. What is the ratio of the Expenses (in $) in Norway in 2006 to that in 2009?
Offer a very short reply. 1.09. What is the ratio of the Expenses (in $) of Paraguay in 2006 to that in 2009?
Ensure brevity in your answer.  1.19. What is the ratio of the Expenses (in $) in San Marino in 2006 to that in 2009?
Ensure brevity in your answer.  1.7. What is the ratio of the Expenses (in $) of Moldova in 2006 to that in 2010?
Your answer should be compact. 0.78. What is the ratio of the Expenses (in $) of Norway in 2006 to that in 2010?
Give a very brief answer. 1.17. What is the ratio of the Expenses (in $) of Paraguay in 2006 to that in 2010?
Make the answer very short. 1.49. What is the ratio of the Expenses (in $) of San Marino in 2006 to that in 2010?
Your response must be concise. 2.36. What is the ratio of the Expenses (in $) of Moldova in 2006 to that in 2011?
Your response must be concise. 0.65. What is the ratio of the Expenses (in $) of Norway in 2006 to that in 2011?
Your answer should be compact. 1.41. What is the ratio of the Expenses (in $) of Paraguay in 2006 to that in 2011?
Give a very brief answer. 1.82. What is the ratio of the Expenses (in $) of San Marino in 2006 to that in 2011?
Keep it short and to the point. 2.24. What is the ratio of the Expenses (in $) of Moldova in 2007 to that in 2008?
Offer a very short reply. 0.85. What is the ratio of the Expenses (in $) in Norway in 2007 to that in 2008?
Your answer should be compact. 0.87. What is the ratio of the Expenses (in $) in Paraguay in 2007 to that in 2008?
Ensure brevity in your answer.  1.15. What is the ratio of the Expenses (in $) in San Marino in 2007 to that in 2008?
Provide a short and direct response. 2.13. What is the ratio of the Expenses (in $) in Moldova in 2007 to that in 2009?
Keep it short and to the point. 0.73. What is the ratio of the Expenses (in $) of Norway in 2007 to that in 2009?
Ensure brevity in your answer.  0.79. What is the ratio of the Expenses (in $) of Paraguay in 2007 to that in 2009?
Provide a short and direct response. 1.18. What is the ratio of the Expenses (in $) in San Marino in 2007 to that in 2009?
Your answer should be very brief. 1.98. What is the ratio of the Expenses (in $) of Moldova in 2007 to that in 2010?
Make the answer very short. 1.11. What is the ratio of the Expenses (in $) of Norway in 2007 to that in 2010?
Make the answer very short. 0.85. What is the ratio of the Expenses (in $) in Paraguay in 2007 to that in 2010?
Provide a short and direct response. 1.48. What is the ratio of the Expenses (in $) of San Marino in 2007 to that in 2010?
Provide a succinct answer. 2.74. What is the ratio of the Expenses (in $) of Moldova in 2007 to that in 2011?
Give a very brief answer. 0.92. What is the ratio of the Expenses (in $) of Norway in 2007 to that in 2011?
Give a very brief answer. 1.02. What is the ratio of the Expenses (in $) of Paraguay in 2007 to that in 2011?
Offer a terse response. 1.8. What is the ratio of the Expenses (in $) in San Marino in 2007 to that in 2011?
Give a very brief answer. 2.6. What is the ratio of the Expenses (in $) in Moldova in 2008 to that in 2009?
Provide a short and direct response. 0.86. What is the ratio of the Expenses (in $) of Norway in 2008 to that in 2009?
Give a very brief answer. 0.91. What is the ratio of the Expenses (in $) of Paraguay in 2008 to that in 2009?
Offer a terse response. 1.02. What is the ratio of the Expenses (in $) of San Marino in 2008 to that in 2009?
Provide a short and direct response. 0.93. What is the ratio of the Expenses (in $) of Moldova in 2008 to that in 2010?
Provide a short and direct response. 1.32. What is the ratio of the Expenses (in $) in Norway in 2008 to that in 2010?
Your answer should be very brief. 0.98. What is the ratio of the Expenses (in $) of Paraguay in 2008 to that in 2010?
Keep it short and to the point. 1.29. What is the ratio of the Expenses (in $) in San Marino in 2008 to that in 2010?
Your answer should be very brief. 1.28. What is the ratio of the Expenses (in $) in Moldova in 2008 to that in 2011?
Provide a short and direct response. 1.09. What is the ratio of the Expenses (in $) in Norway in 2008 to that in 2011?
Provide a short and direct response. 1.17. What is the ratio of the Expenses (in $) in Paraguay in 2008 to that in 2011?
Make the answer very short. 1.57. What is the ratio of the Expenses (in $) in San Marino in 2008 to that in 2011?
Provide a short and direct response. 1.22. What is the ratio of the Expenses (in $) of Moldova in 2009 to that in 2010?
Provide a succinct answer. 1.52. What is the ratio of the Expenses (in $) of Norway in 2009 to that in 2010?
Your response must be concise. 1.08. What is the ratio of the Expenses (in $) in Paraguay in 2009 to that in 2010?
Offer a very short reply. 1.25. What is the ratio of the Expenses (in $) in San Marino in 2009 to that in 2010?
Give a very brief answer. 1.39. What is the ratio of the Expenses (in $) of Moldova in 2009 to that in 2011?
Provide a short and direct response. 1.26. What is the ratio of the Expenses (in $) in Norway in 2009 to that in 2011?
Offer a very short reply. 1.29. What is the ratio of the Expenses (in $) in Paraguay in 2009 to that in 2011?
Ensure brevity in your answer.  1.53. What is the ratio of the Expenses (in $) in San Marino in 2009 to that in 2011?
Give a very brief answer. 1.32. What is the ratio of the Expenses (in $) in Moldova in 2010 to that in 2011?
Give a very brief answer. 0.83. What is the ratio of the Expenses (in $) in Norway in 2010 to that in 2011?
Offer a terse response. 1.2. What is the ratio of the Expenses (in $) in Paraguay in 2010 to that in 2011?
Your answer should be compact. 1.22. What is the ratio of the Expenses (in $) of San Marino in 2010 to that in 2011?
Your answer should be compact. 0.95. What is the difference between the highest and the second highest Expenses (in $) in Moldova?
Provide a succinct answer. 1.13e+08. What is the difference between the highest and the second highest Expenses (in $) in Norway?
Your response must be concise. 2.15e+09. What is the difference between the highest and the second highest Expenses (in $) in Paraguay?
Make the answer very short. 2.30e+1. What is the difference between the highest and the second highest Expenses (in $) of San Marino?
Ensure brevity in your answer.  1.77e+06. What is the difference between the highest and the lowest Expenses (in $) of Moldova?
Offer a terse response. 4.06e+08. What is the difference between the highest and the lowest Expenses (in $) in Norway?
Your answer should be compact. 8.89e+09. What is the difference between the highest and the lowest Expenses (in $) of Paraguay?
Your response must be concise. 2.56e+11. What is the difference between the highest and the lowest Expenses (in $) of San Marino?
Offer a very short reply. 9.97e+06. 